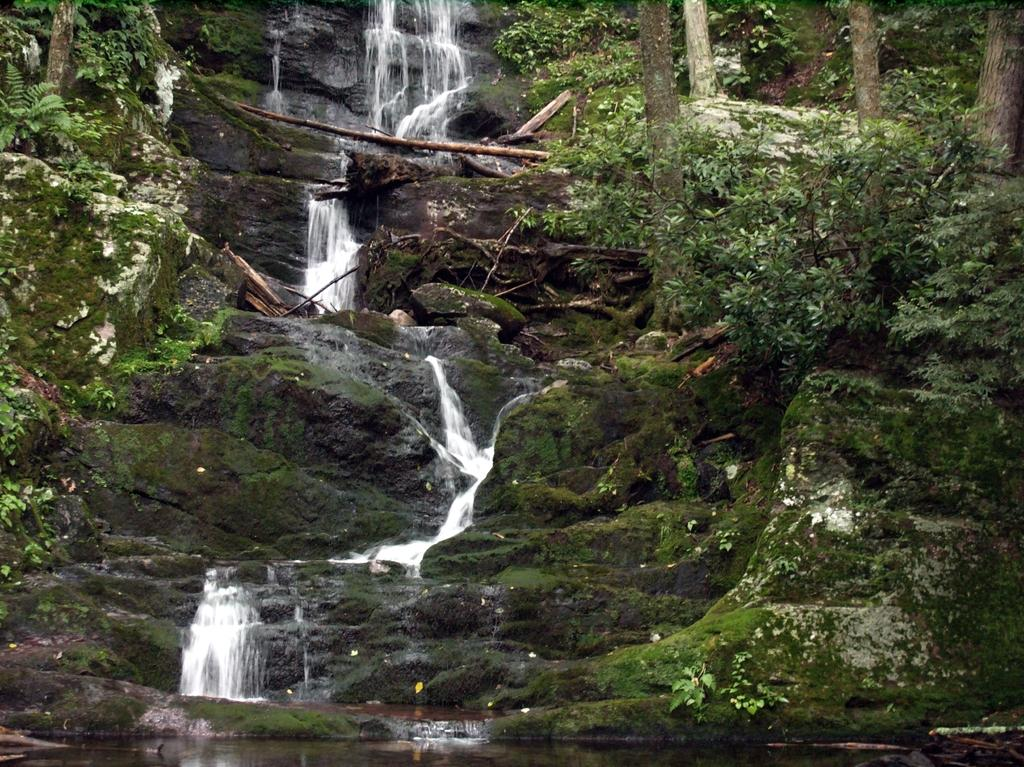What type of landscape feature is present in the image? There is a hill in the image. What type of vegetation can be seen in the image? There is grass and trees visible in the image. What natural element is present in the image? There is water visible in the image. What type of club is being used to hit the ball in the image? There is no ball or club present in the image; it features a hill, grass, trees, and water. 